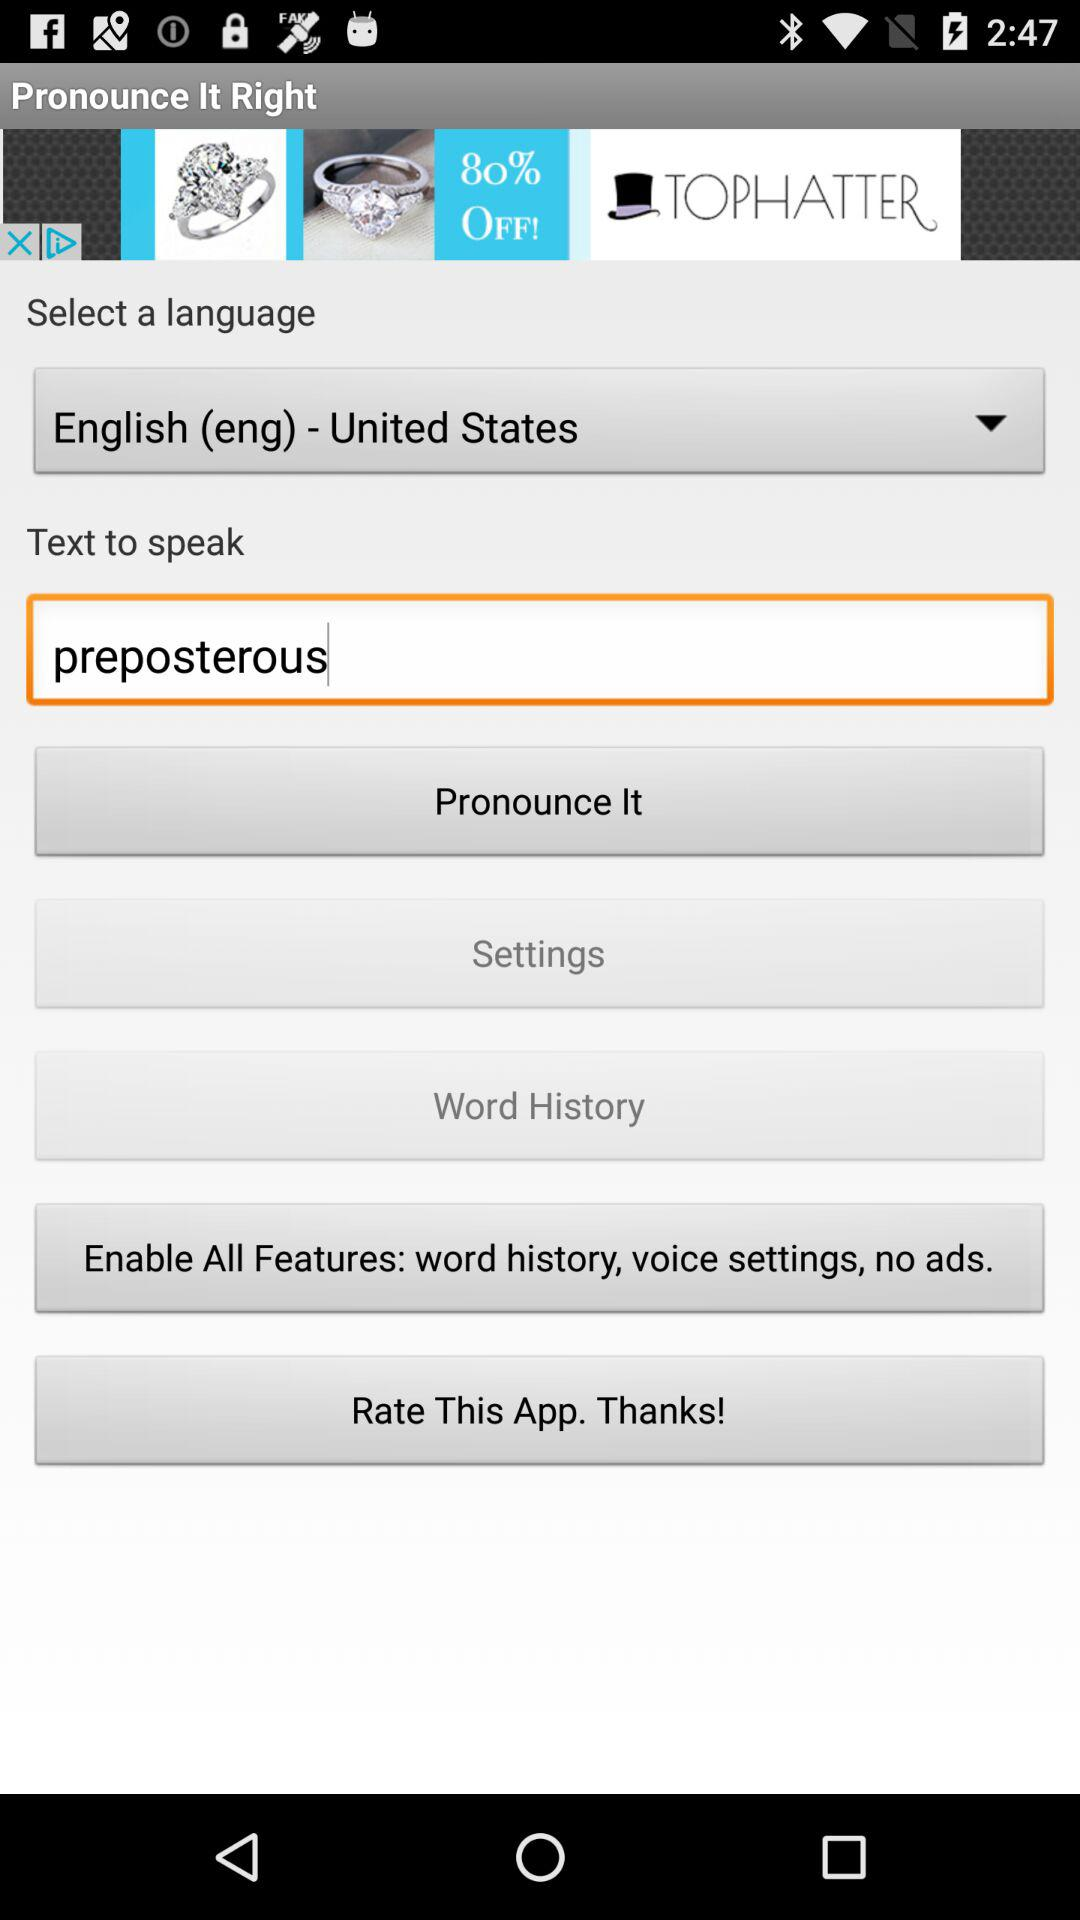How many notifications are there in "Settings"?
When the provided information is insufficient, respond with <no answer>. <no answer> 